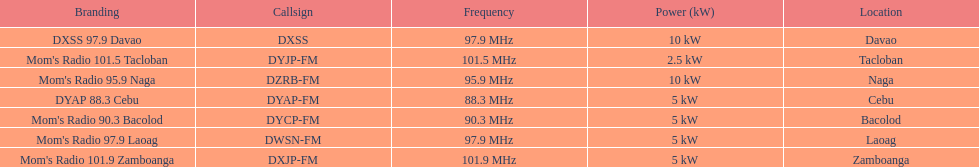How many times is the frequency greater than 95? 5. 